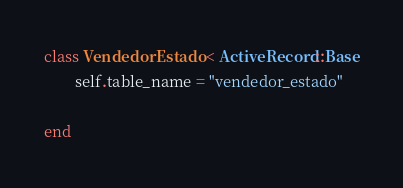Convert code to text. <code><loc_0><loc_0><loc_500><loc_500><_Ruby_>class VendedorEstado < ActiveRecord::Base
		self.table_name = "vendedor_estado"

end
</code> 